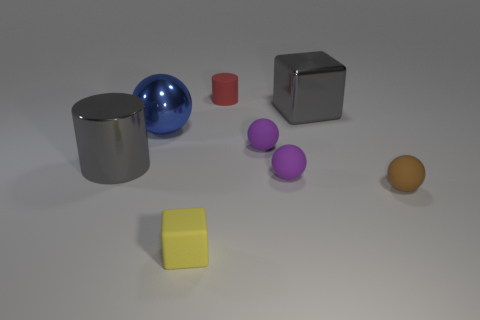How many objects are there in the image, and can you describe them? There are seven objects in the image: a large gray cylinder, a reflective blue sphere, a small red cube, a metallic silver cube, two smaller purple spheres, and a yellow cube. 